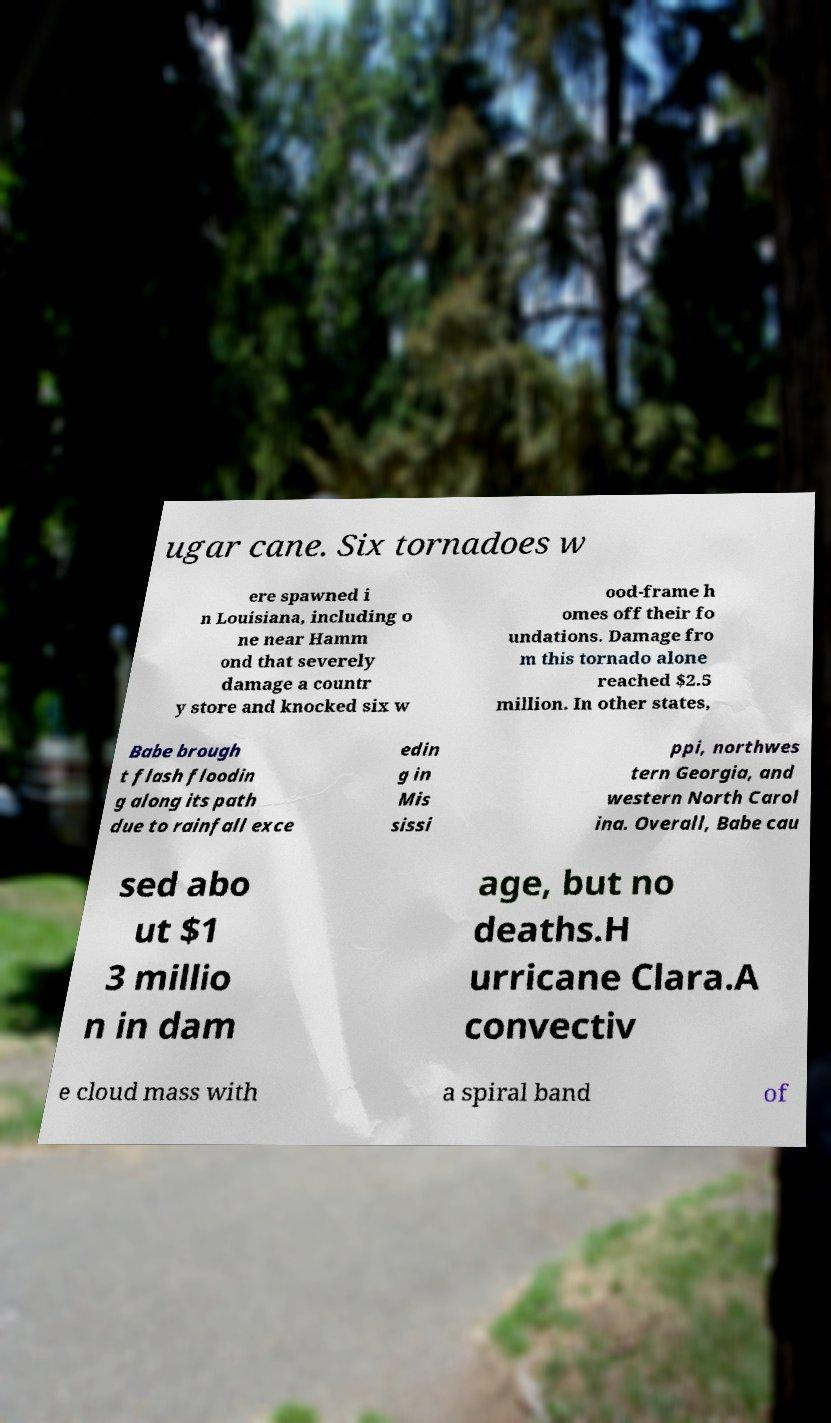Could you extract and type out the text from this image? ugar cane. Six tornadoes w ere spawned i n Louisiana, including o ne near Hamm ond that severely damage a countr y store and knocked six w ood-frame h omes off their fo undations. Damage fro m this tornado alone reached $2.5 million. In other states, Babe brough t flash floodin g along its path due to rainfall exce edin g in Mis sissi ppi, northwes tern Georgia, and western North Carol ina. Overall, Babe cau sed abo ut $1 3 millio n in dam age, but no deaths.H urricane Clara.A convectiv e cloud mass with a spiral band of 